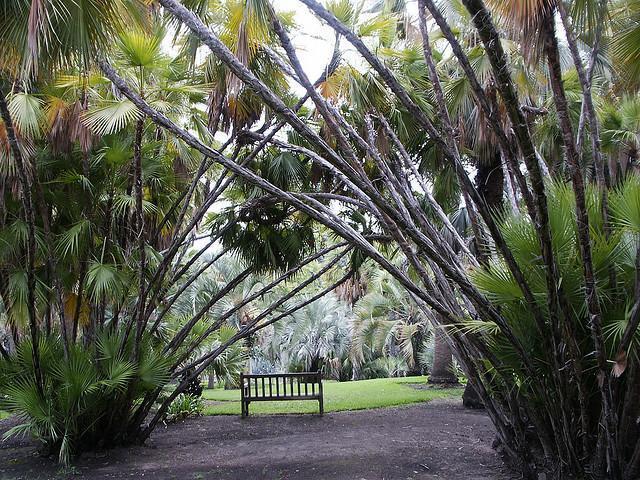How many benches are visible?
Give a very brief answer. 1. 